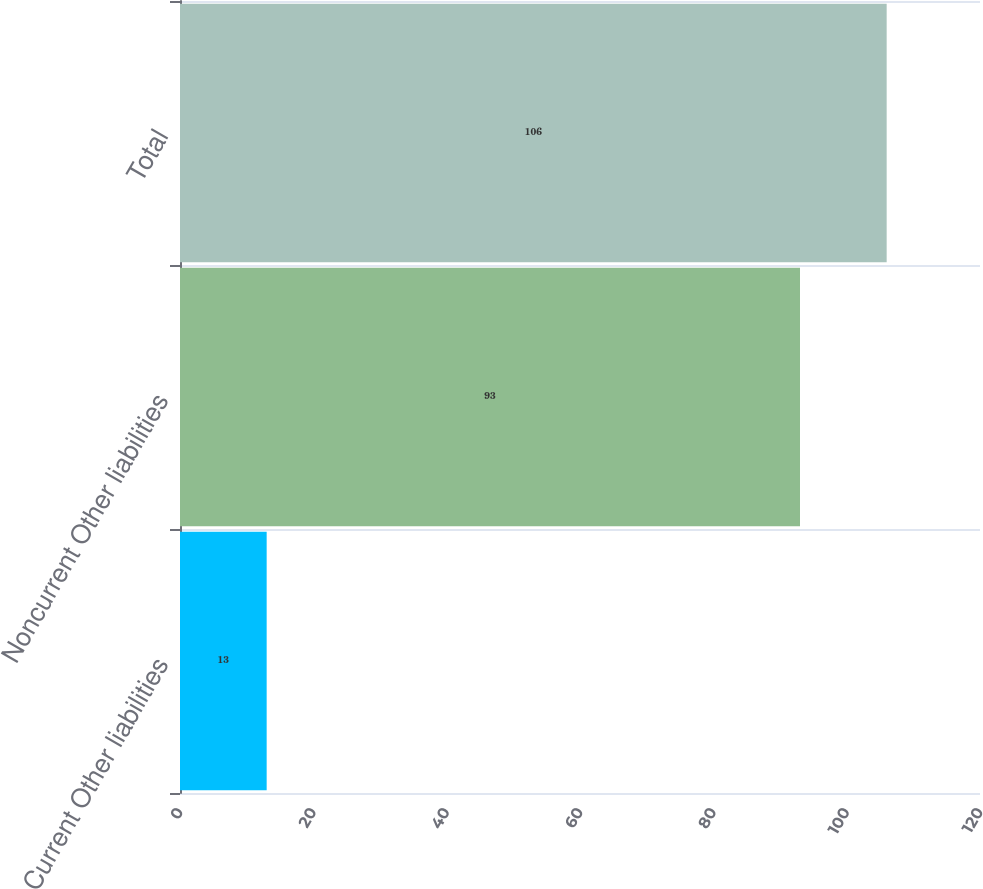Convert chart to OTSL. <chart><loc_0><loc_0><loc_500><loc_500><bar_chart><fcel>Current Other liabilities<fcel>Noncurrent Other liabilities<fcel>Total<nl><fcel>13<fcel>93<fcel>106<nl></chart> 